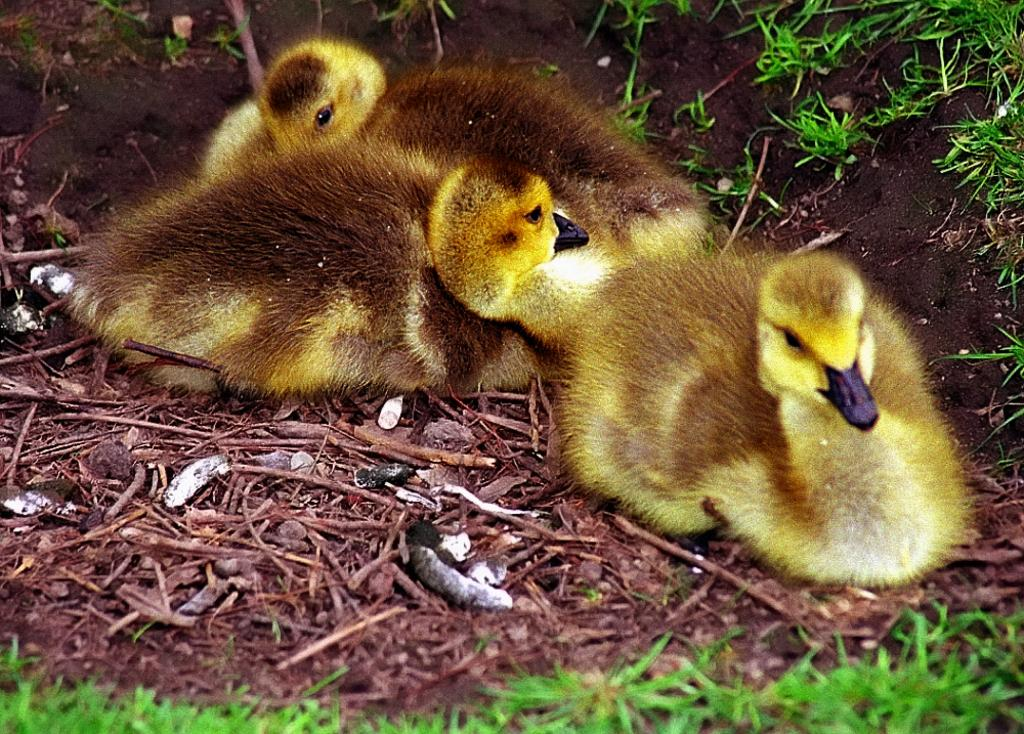What is the main subject in the center of the image? There are ducklings in the center of the image. What type of natural environment is visible in the image? There is greenery in the image. What type of fan can be seen in the image? There is no fan present in the image. Are there any sand dunes visible in the image? There is no sand or sand dunes visible in the image. Can you see any slaves in the image? There is no reference to any slaves in the image. 